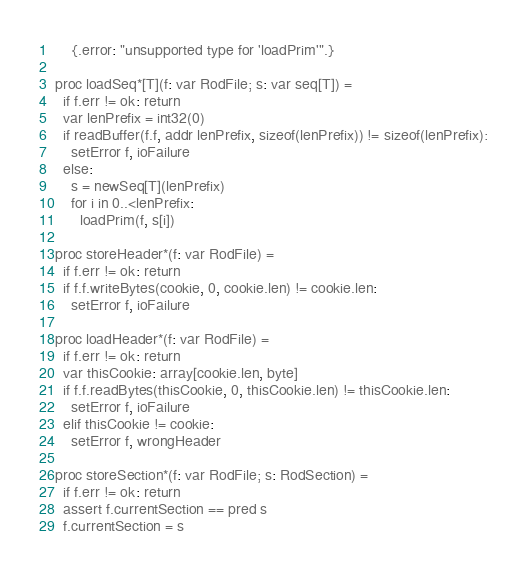Convert code to text. <code><loc_0><loc_0><loc_500><loc_500><_Nim_>    {.error: "unsupported type for 'loadPrim'".}

proc loadSeq*[T](f: var RodFile; s: var seq[T]) =
  if f.err != ok: return
  var lenPrefix = int32(0)
  if readBuffer(f.f, addr lenPrefix, sizeof(lenPrefix)) != sizeof(lenPrefix):
    setError f, ioFailure
  else:
    s = newSeq[T](lenPrefix)
    for i in 0..<lenPrefix:
      loadPrim(f, s[i])

proc storeHeader*(f: var RodFile) =
  if f.err != ok: return
  if f.f.writeBytes(cookie, 0, cookie.len) != cookie.len:
    setError f, ioFailure

proc loadHeader*(f: var RodFile) =
  if f.err != ok: return
  var thisCookie: array[cookie.len, byte]
  if f.f.readBytes(thisCookie, 0, thisCookie.len) != thisCookie.len:
    setError f, ioFailure
  elif thisCookie != cookie:
    setError f, wrongHeader

proc storeSection*(f: var RodFile; s: RodSection) =
  if f.err != ok: return
  assert f.currentSection == pred s
  f.currentSection = s</code> 